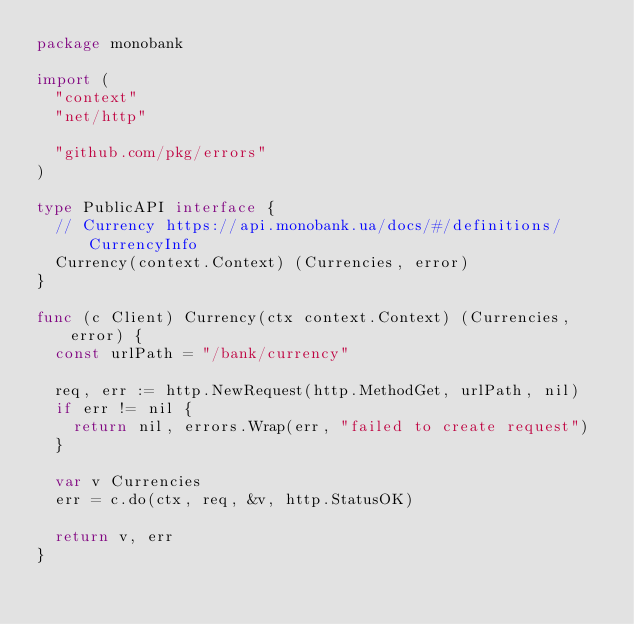<code> <loc_0><loc_0><loc_500><loc_500><_Go_>package monobank

import (
	"context"
	"net/http"

	"github.com/pkg/errors"
)

type PublicAPI interface {
	// Currency https://api.monobank.ua/docs/#/definitions/CurrencyInfo
	Currency(context.Context) (Currencies, error)
}

func (c Client) Currency(ctx context.Context) (Currencies, error) {
	const urlPath = "/bank/currency"

	req, err := http.NewRequest(http.MethodGet, urlPath, nil)
	if err != nil {
		return nil, errors.Wrap(err, "failed to create request")
	}

	var v Currencies
	err = c.do(ctx, req, &v, http.StatusOK)

	return v, err
}
</code> 